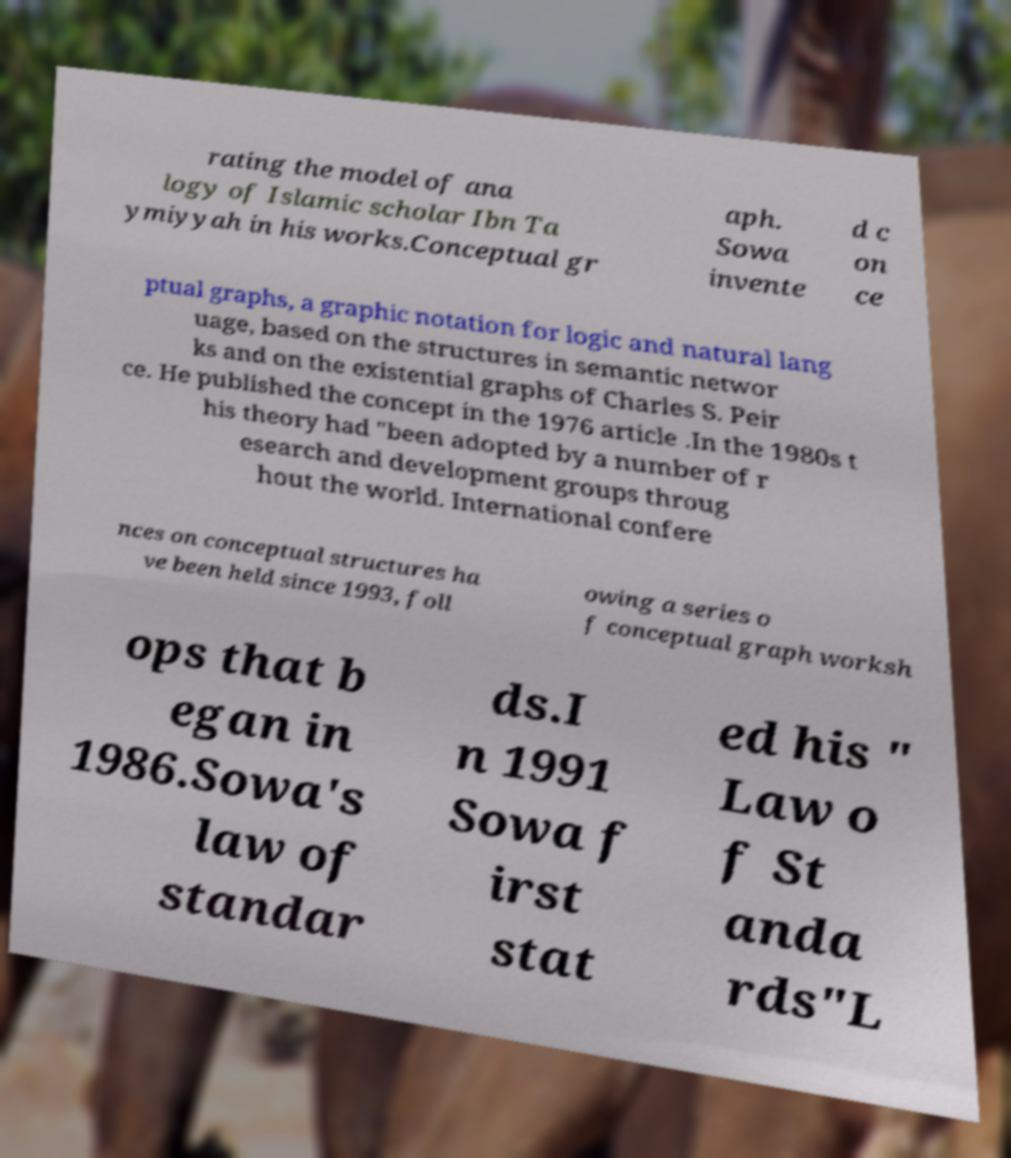I need the written content from this picture converted into text. Can you do that? rating the model of ana logy of Islamic scholar Ibn Ta ymiyyah in his works.Conceptual gr aph. Sowa invente d c on ce ptual graphs, a graphic notation for logic and natural lang uage, based on the structures in semantic networ ks and on the existential graphs of Charles S. Peir ce. He published the concept in the 1976 article .In the 1980s t his theory had "been adopted by a number of r esearch and development groups throug hout the world. International confere nces on conceptual structures ha ve been held since 1993, foll owing a series o f conceptual graph worksh ops that b egan in 1986.Sowa's law of standar ds.I n 1991 Sowa f irst stat ed his " Law o f St anda rds"L 